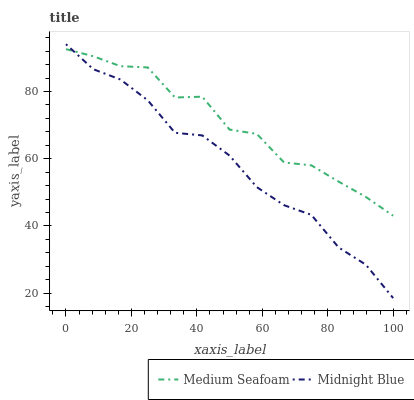Does Midnight Blue have the minimum area under the curve?
Answer yes or no. Yes. Does Medium Seafoam have the maximum area under the curve?
Answer yes or no. Yes. Does Midnight Blue have the maximum area under the curve?
Answer yes or no. No. Is Midnight Blue the smoothest?
Answer yes or no. Yes. Is Medium Seafoam the roughest?
Answer yes or no. Yes. Is Midnight Blue the roughest?
Answer yes or no. No. Does Midnight Blue have the lowest value?
Answer yes or no. Yes. Does Midnight Blue have the highest value?
Answer yes or no. Yes. Does Midnight Blue intersect Medium Seafoam?
Answer yes or no. Yes. Is Midnight Blue less than Medium Seafoam?
Answer yes or no. No. Is Midnight Blue greater than Medium Seafoam?
Answer yes or no. No. 